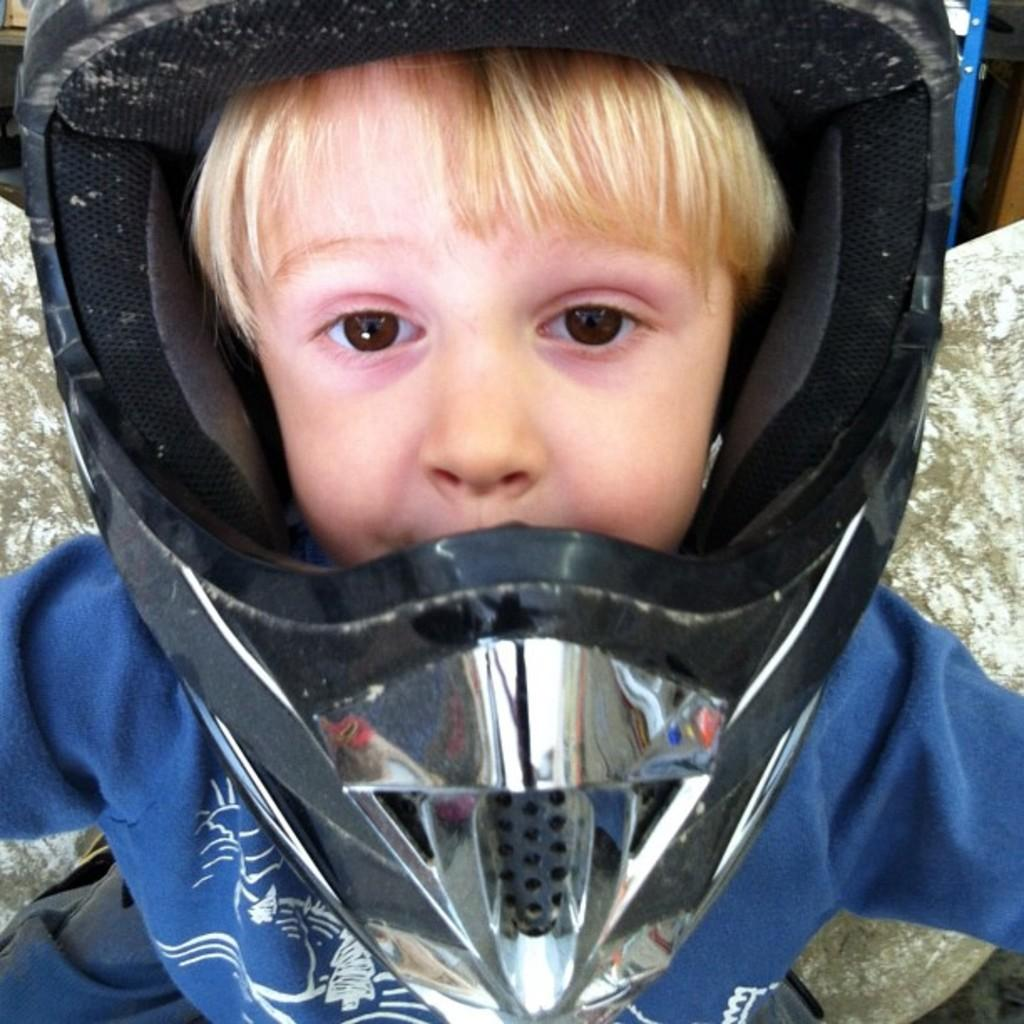What is the main subject of the image? There is a baby in the image. What is the baby wearing? The baby is wearing a blue dress. What accessory is the baby wearing on his head? The baby has a helmet on his head. What type of caption is written under the baby in the image? There is no caption written under the baby in the image. What agreement was made between the baby and the photographer before taking the picture? There is no information about any agreement made between the baby and the photographer, as the facts provided do not mention any interaction or communication. 